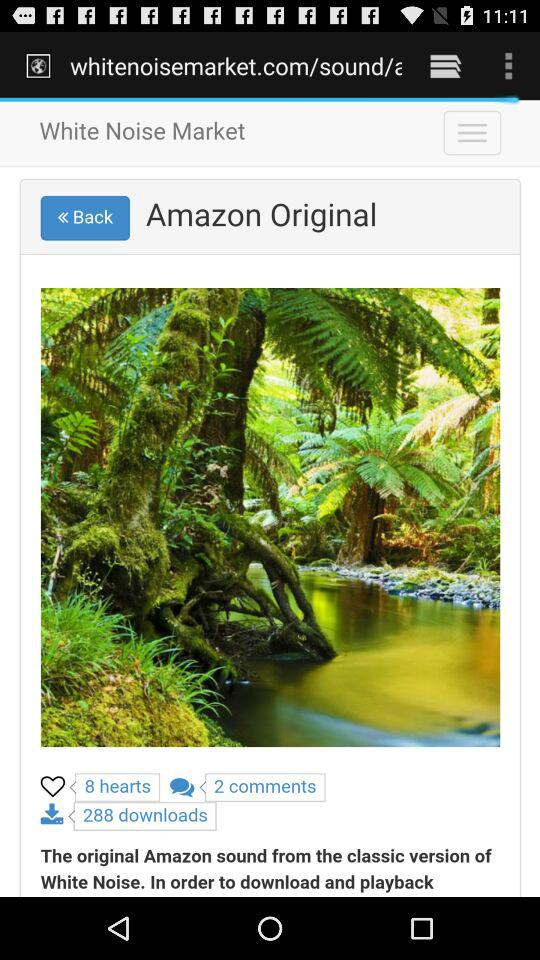How many comments are shown? There are 2 comments. 